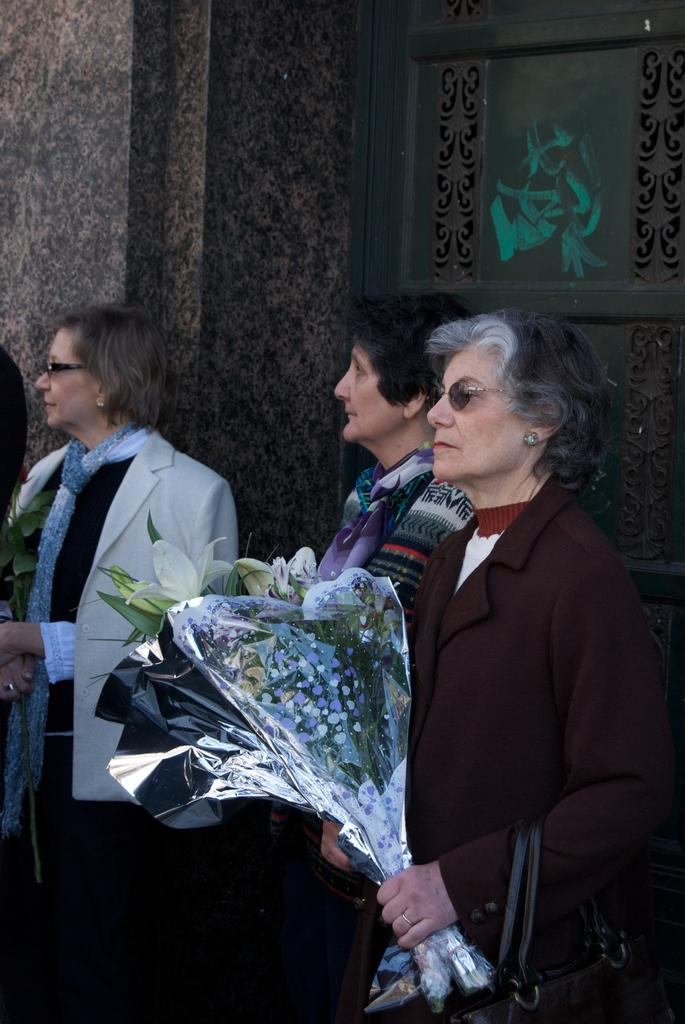How many women are in the image? There are three women in the image. What are the women wearing? The women are wearing different color dresses. What are the women doing in the image? The women are standing. What are two of the women holding? Two of the women are holding flower Buckeyes. What can be seen in the background of the image? There is a building in the background of the image. What feature of the building is mentioned? The building has a door. What type of street is visible in the image? There is no street visible in the image; it features three women, flower Buckeyes, and a building with a door. Can you see a monkey in the image? No, there is no monkey present in the image. 